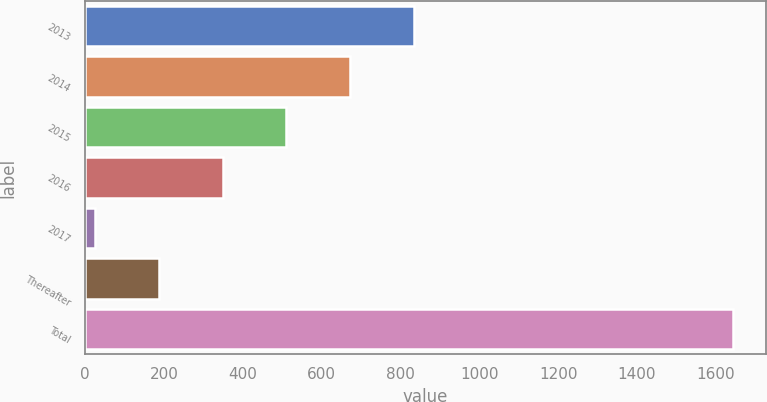Convert chart. <chart><loc_0><loc_0><loc_500><loc_500><bar_chart><fcel>2013<fcel>2014<fcel>2015<fcel>2016<fcel>2017<fcel>Thereafter<fcel>Total<nl><fcel>834.5<fcel>672.6<fcel>510.7<fcel>348.8<fcel>25<fcel>186.9<fcel>1644<nl></chart> 